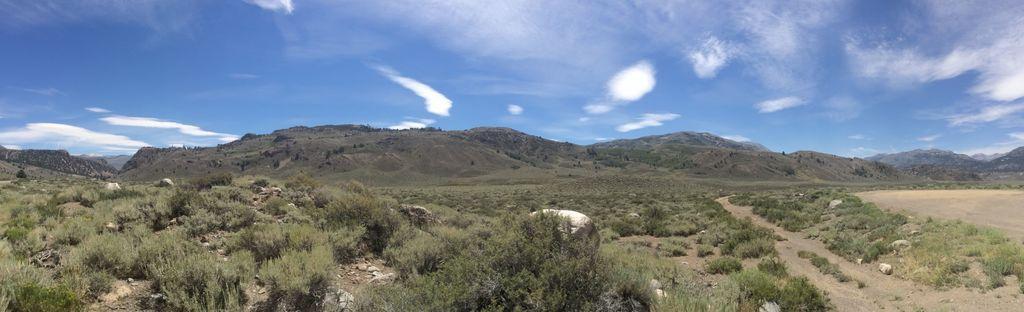How would you summarize this image in a sentence or two? In this image we can see some plants, mountains, rocks, also we can see the sky. 